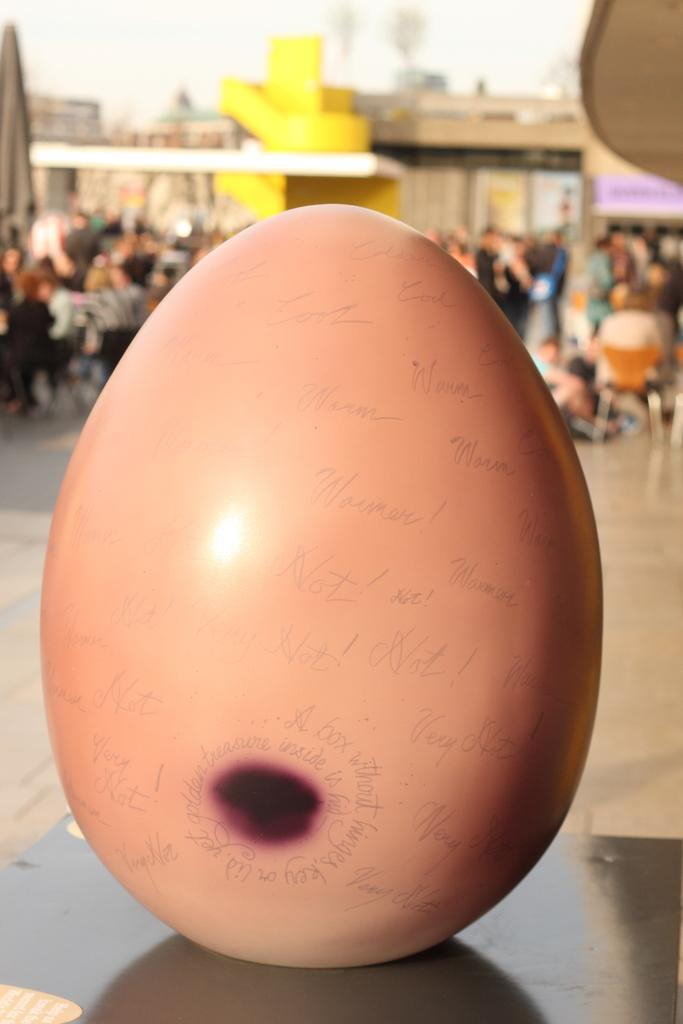What is the main subject of the picture? The main subject of the picture is an egg. What is unique about the egg in the picture? There is writing on the egg. What can be seen in the background of the picture? There are people, chairs, and buildings in the background of the picture. What type of throat medicine is being advertised on the egg in the image? There is no throat medicine or advertisement present on the egg in the image; it only has writing on it. Can you hear the acoustics of the baseball game in the background of the image? There is no baseball game or any sound mentioned in the image; it only shows an egg with writing and a background with people, chairs, and buildings. 